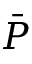Convert formula to latex. <formula><loc_0><loc_0><loc_500><loc_500>\bar { P }</formula> 